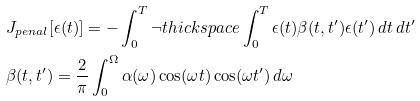<formula> <loc_0><loc_0><loc_500><loc_500>& J _ { p e n a l } [ \epsilon ( t ) ] = - \int _ { 0 } ^ { T } \neg t h i c k s p a c e \int _ { 0 } ^ { T } \epsilon ( t ) \beta ( t , t ^ { \prime } ) \epsilon ( t ^ { \prime } ) \, d t \, d t ^ { \prime } \\ & \beta ( t , t ^ { \prime } ) = \frac { 2 } { \pi } \int _ { 0 } ^ { \Omega } \alpha ( \omega ) \cos ( \omega t ) \cos ( \omega t ^ { \prime } ) \, d \omega</formula> 